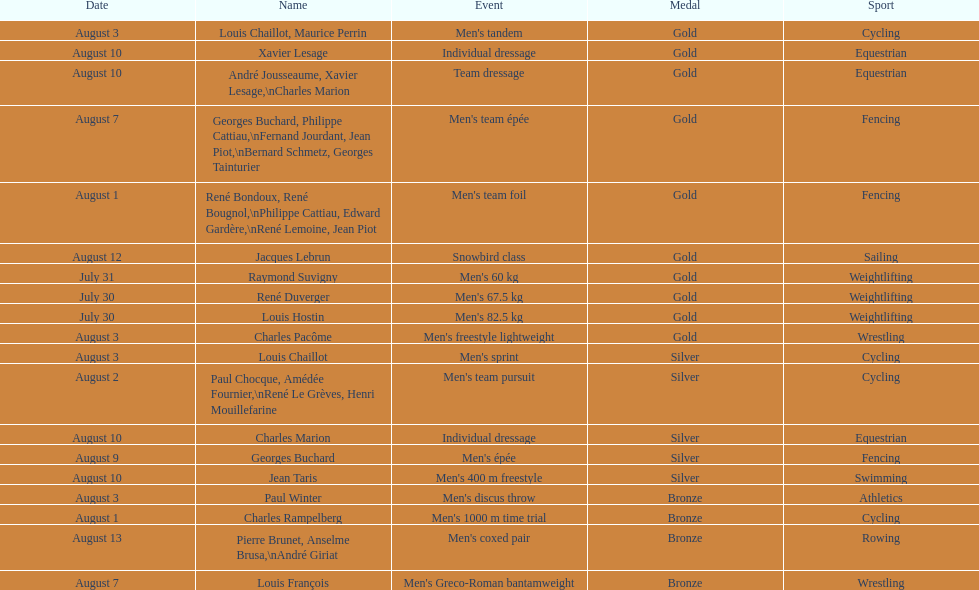Louis chaillot won a gold medal for cycling and a silver medal for what sport? Cycling. 